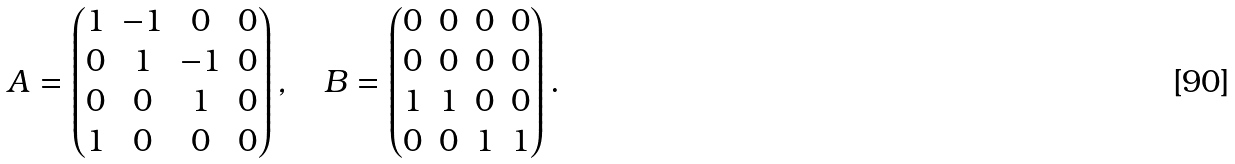<formula> <loc_0><loc_0><loc_500><loc_500>A = \begin{pmatrix} 1 & - 1 & 0 & 0 \\ 0 & 1 & - 1 & 0 \\ 0 & 0 & 1 & 0 \\ 1 & 0 & 0 & 0 \end{pmatrix} , \quad B = \begin{pmatrix} 0 & 0 & 0 & 0 \\ 0 & 0 & 0 & 0 \\ 1 & 1 & 0 & 0 \\ 0 & 0 & 1 & 1 \end{pmatrix} .</formula> 